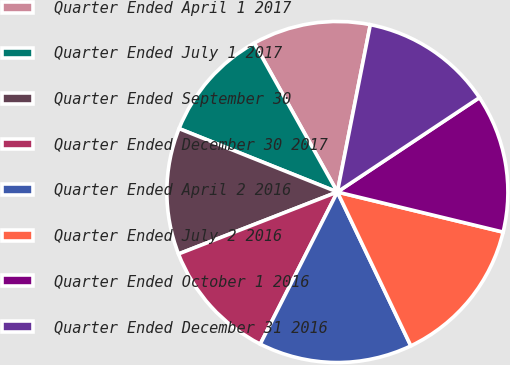<chart> <loc_0><loc_0><loc_500><loc_500><pie_chart><fcel>Quarter Ended April 1 2017<fcel>Quarter Ended July 1 2017<fcel>Quarter Ended September 30<fcel>Quarter Ended December 30 2017<fcel>Quarter Ended April 2 2016<fcel>Quarter Ended July 2 2016<fcel>Quarter Ended October 1 2016<fcel>Quarter Ended December 31 2016<nl><fcel>11.2%<fcel>10.83%<fcel>11.98%<fcel>11.61%<fcel>14.56%<fcel>14.13%<fcel>13.11%<fcel>12.57%<nl></chart> 